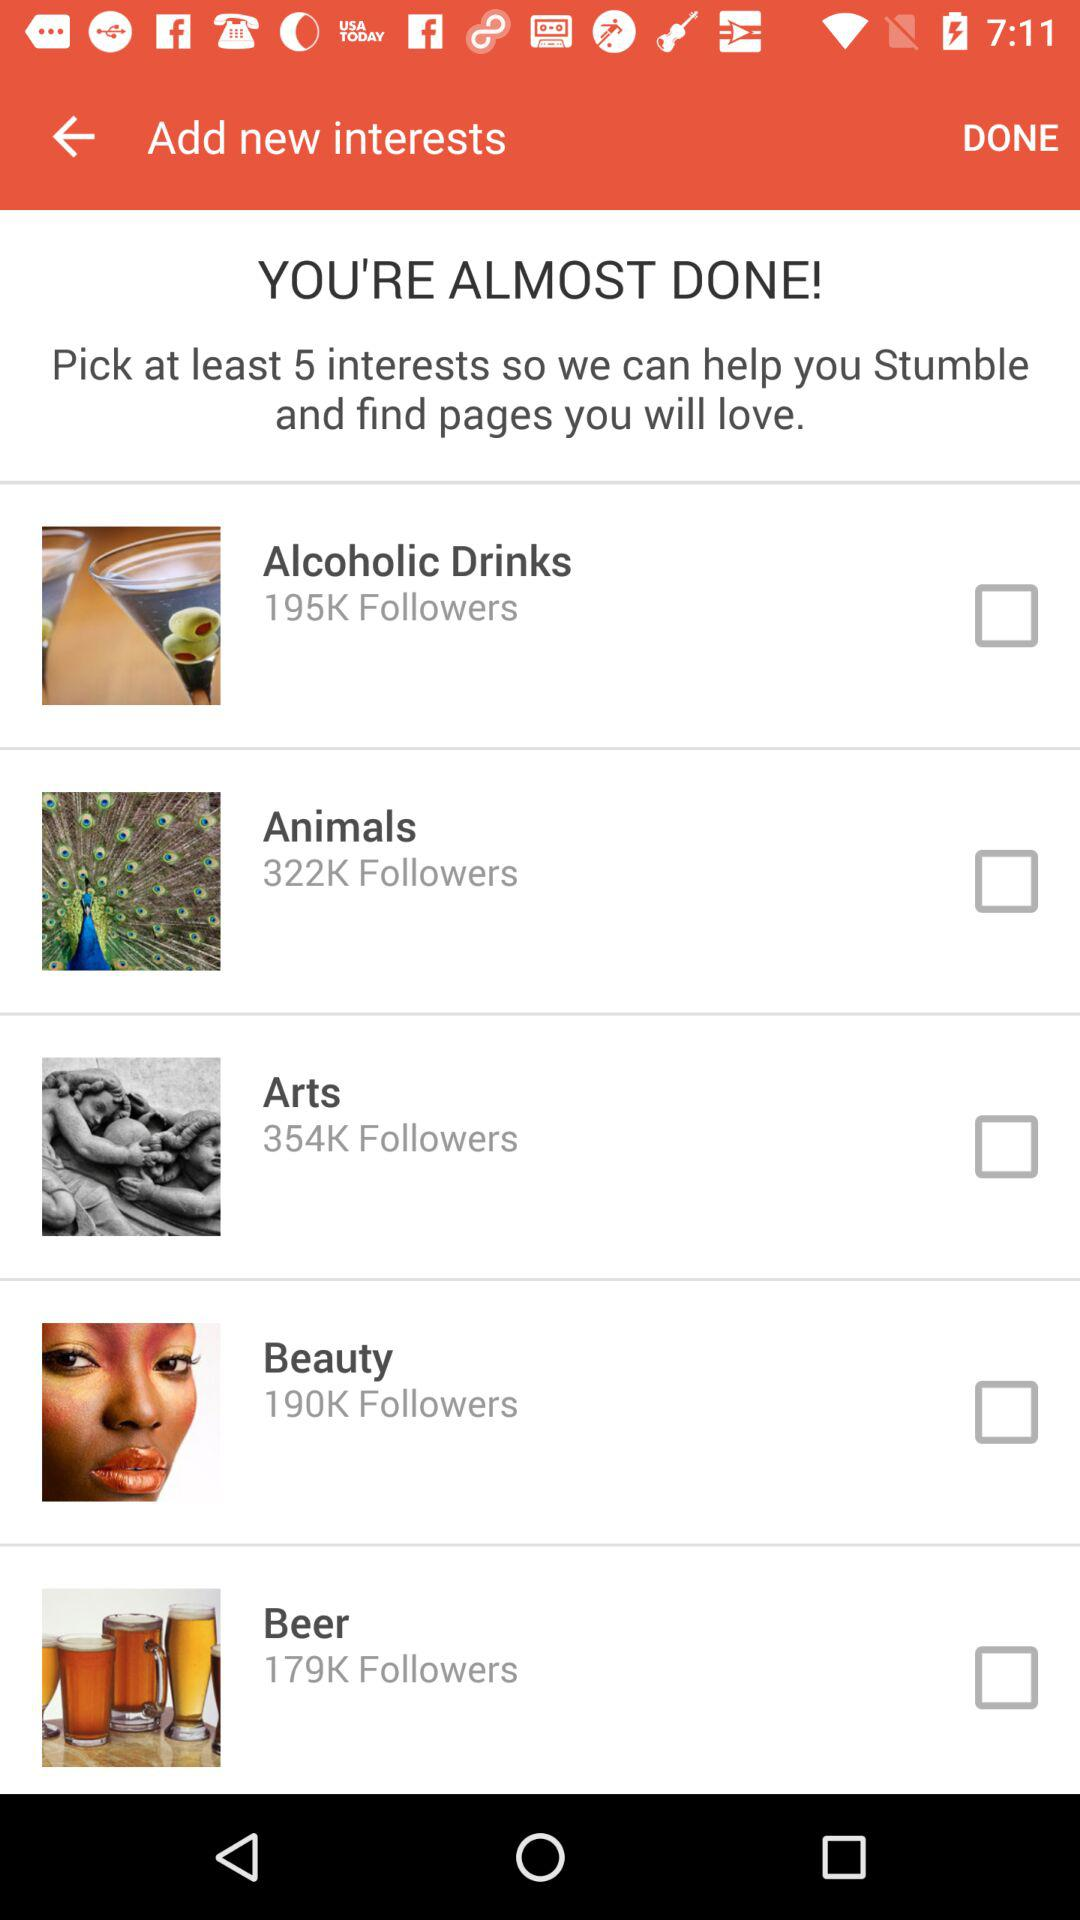How many interests are there?
Answer the question using a single word or phrase. 5 